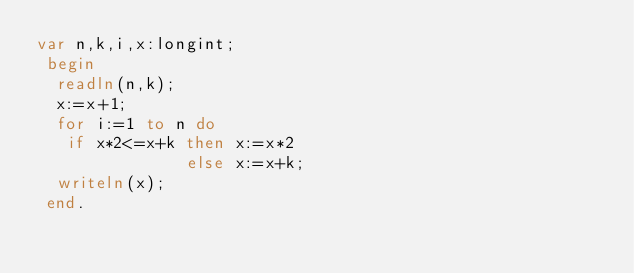Convert code to text. <code><loc_0><loc_0><loc_500><loc_500><_Pascal_>var n,k,i,x:longint;
 begin
  readln(n,k);
  x:=x+1;
  for i:=1 to n do
   if x*2<=x+k then x:=x*2 
               else x:=x+k;
  writeln(x);
 end.</code> 